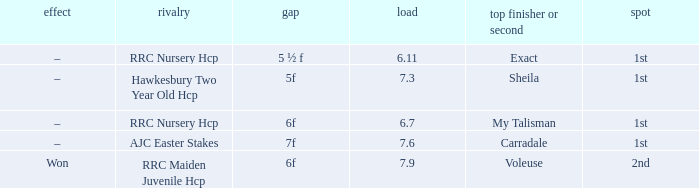Parse the full table. {'header': ['effect', 'rivalry', 'gap', 'load', 'top finisher or second', 'spot'], 'rows': [['–', 'RRC Nursery Hcp', '5 ½ f', '6.11', 'Exact', '1st'], ['–', 'Hawkesbury Two Year Old Hcp', '5f', '7.3', 'Sheila', '1st'], ['–', 'RRC Nursery Hcp', '6f', '6.7', 'My Talisman', '1st'], ['–', 'AJC Easter Stakes', '7f', '7.6', 'Carradale', '1st'], ['Won', 'RRC Maiden Juvenile Hcp', '6f', '7.9', 'Voleuse', '2nd']]} What is the weight number when the distance was 5 ½ f? 1.0. 